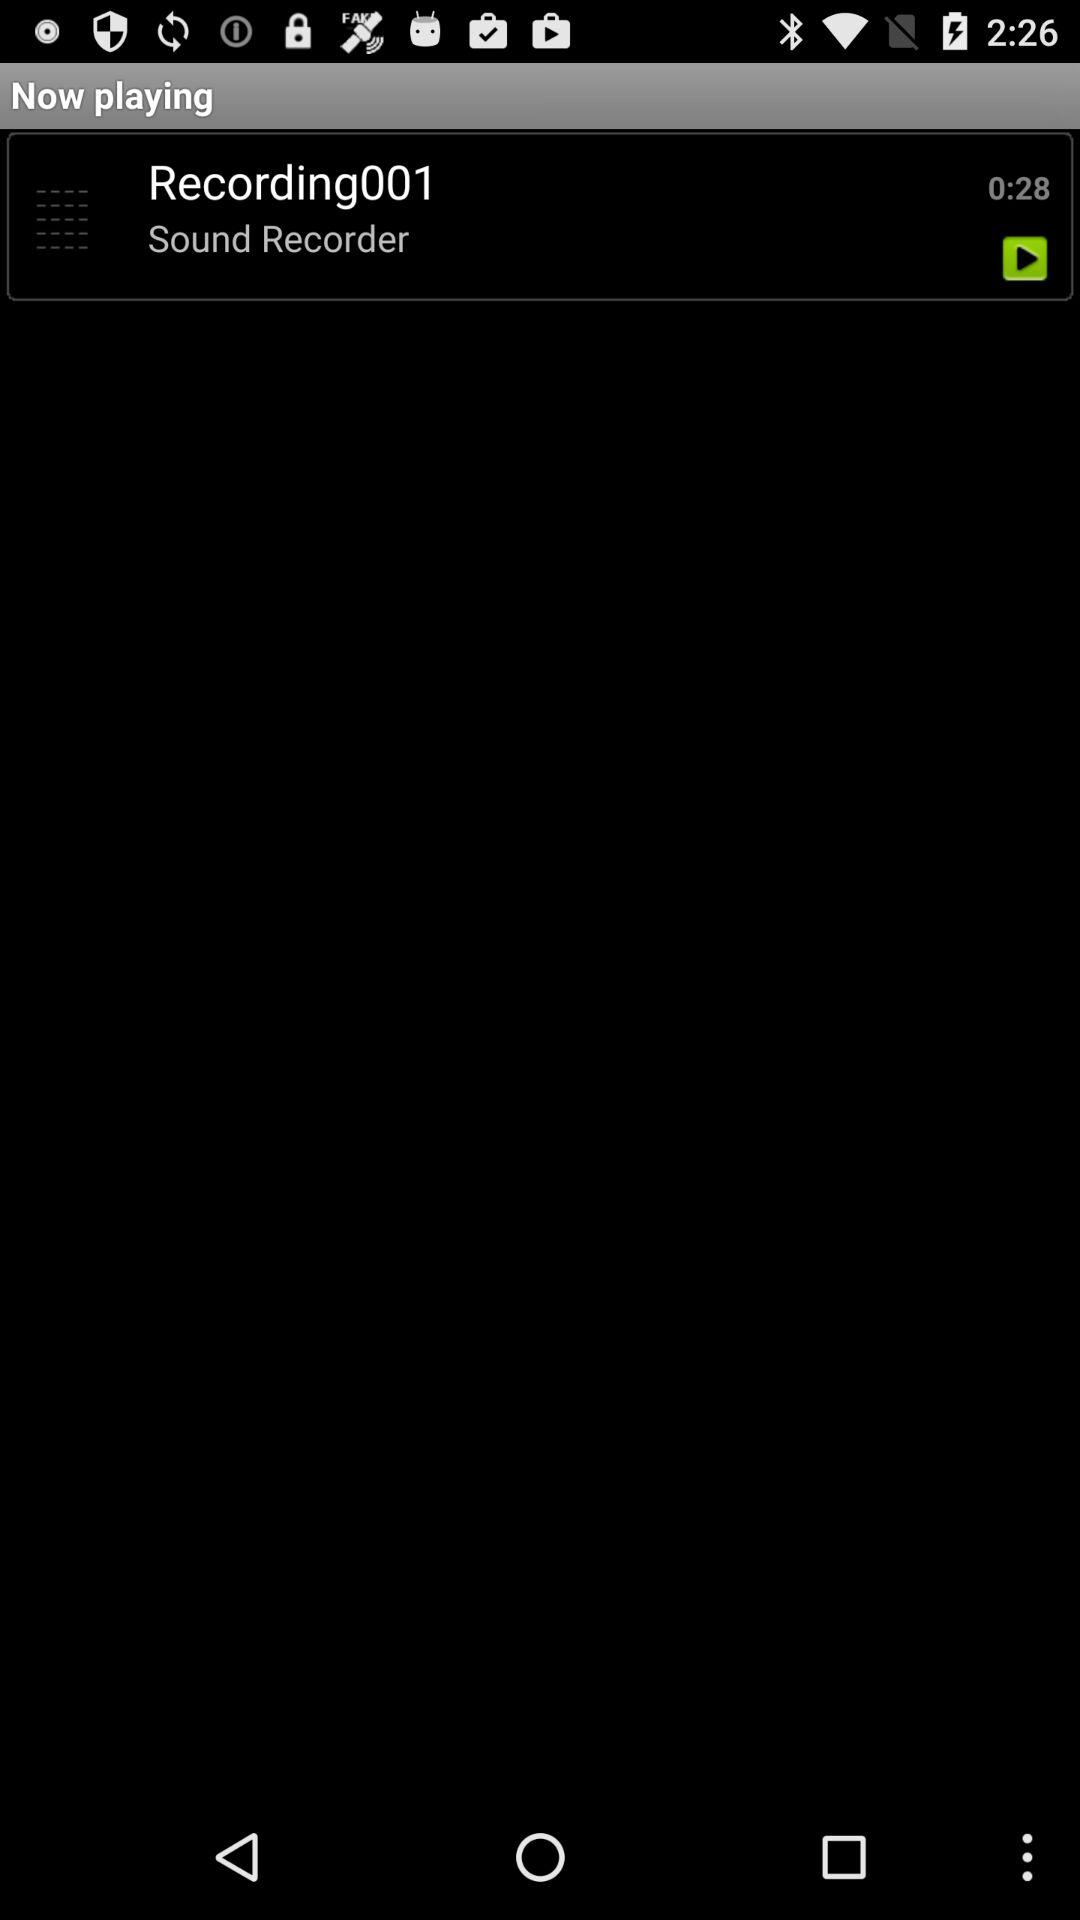What is the length of the audio? The length of audio is "0:28". 